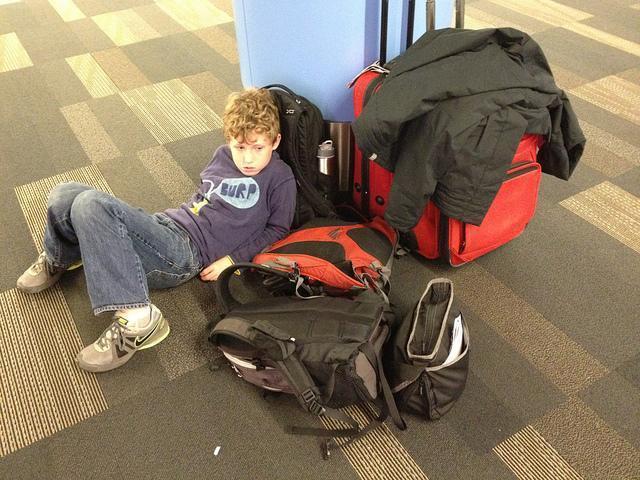How many backpacks are there?
Give a very brief answer. 3. 